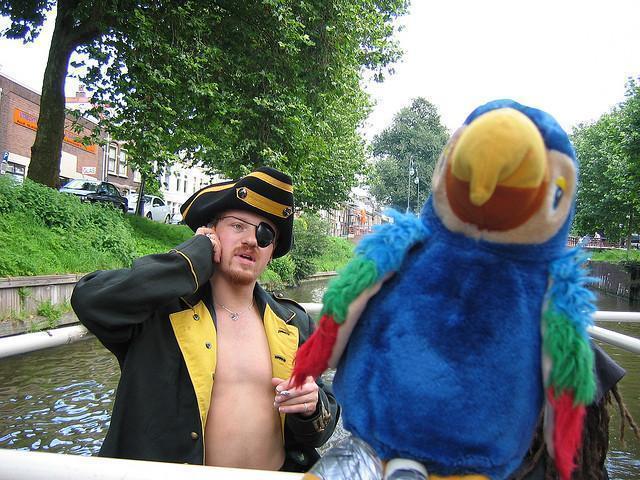What is the shirtless man dressed as?
Answer the question by selecting the correct answer among the 4 following choices.
Options: Pirate, wrestler, cop, prisoner. Pirate. 